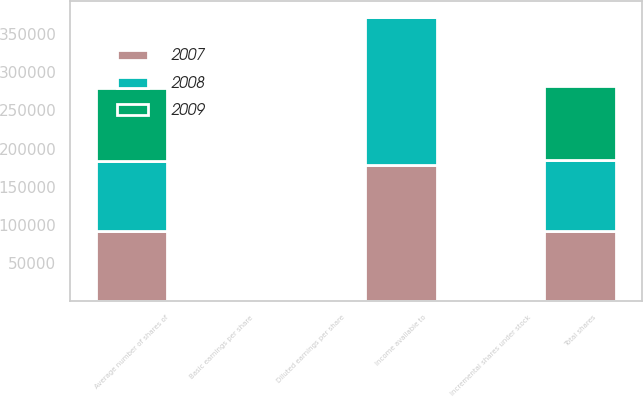Convert chart to OTSL. <chart><loc_0><loc_0><loc_500><loc_500><stacked_bar_chart><ecel><fcel>Income available to<fcel>Average number of shares of<fcel>Basic earnings per share<fcel>Incremental shares under stock<fcel>Total shares<fcel>Diluted earnings per share<nl><fcel>2007<fcel>178368<fcel>91512<fcel>1.95<fcel>534<fcel>92046<fcel>1.94<nl><fcel>2008<fcel>194202<fcel>91657<fcel>2.12<fcel>1084<fcel>92741<fcel>2.09<nl><fcel>2009<fcel>1900<fcel>95496<fcel>2.41<fcel>1900<fcel>97396<fcel>2.36<nl></chart> 